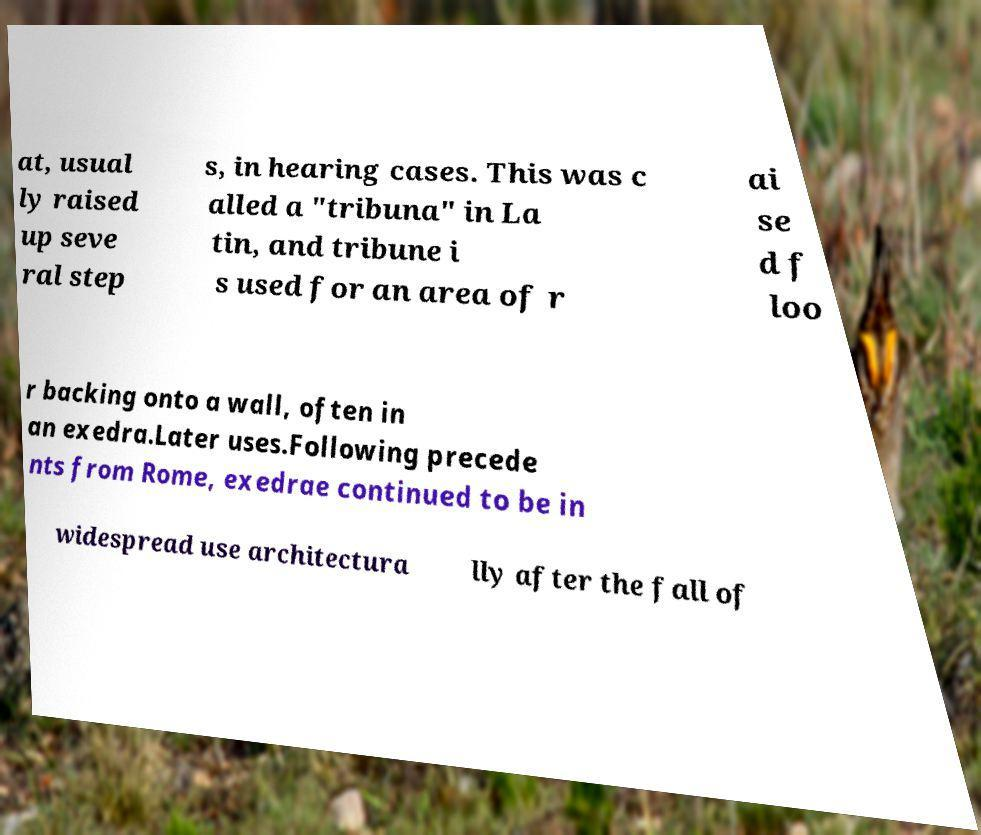What messages or text are displayed in this image? I need them in a readable, typed format. at, usual ly raised up seve ral step s, in hearing cases. This was c alled a "tribuna" in La tin, and tribune i s used for an area of r ai se d f loo r backing onto a wall, often in an exedra.Later uses.Following precede nts from Rome, exedrae continued to be in widespread use architectura lly after the fall of 